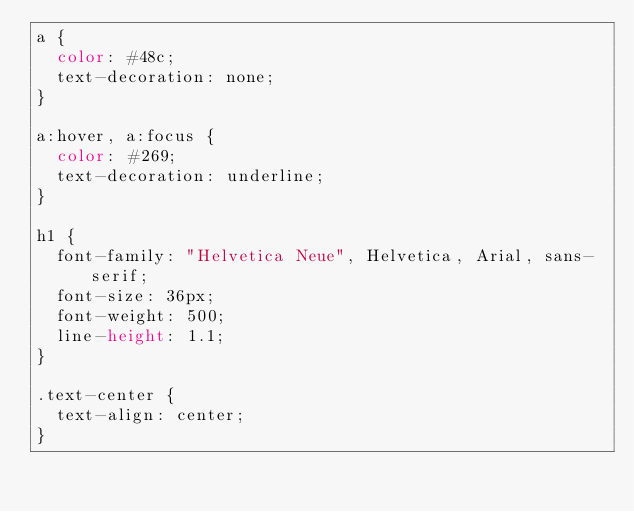Convert code to text. <code><loc_0><loc_0><loc_500><loc_500><_CSS_>a {
  color: #48c;
  text-decoration: none;
}

a:hover, a:focus {
  color: #269;
  text-decoration: underline;
}

h1 {
  font-family: "Helvetica Neue", Helvetica, Arial, sans-serif;
  font-size: 36px;
  font-weight: 500;
  line-height: 1.1;
}

.text-center {
  text-align: center;
}
</code> 